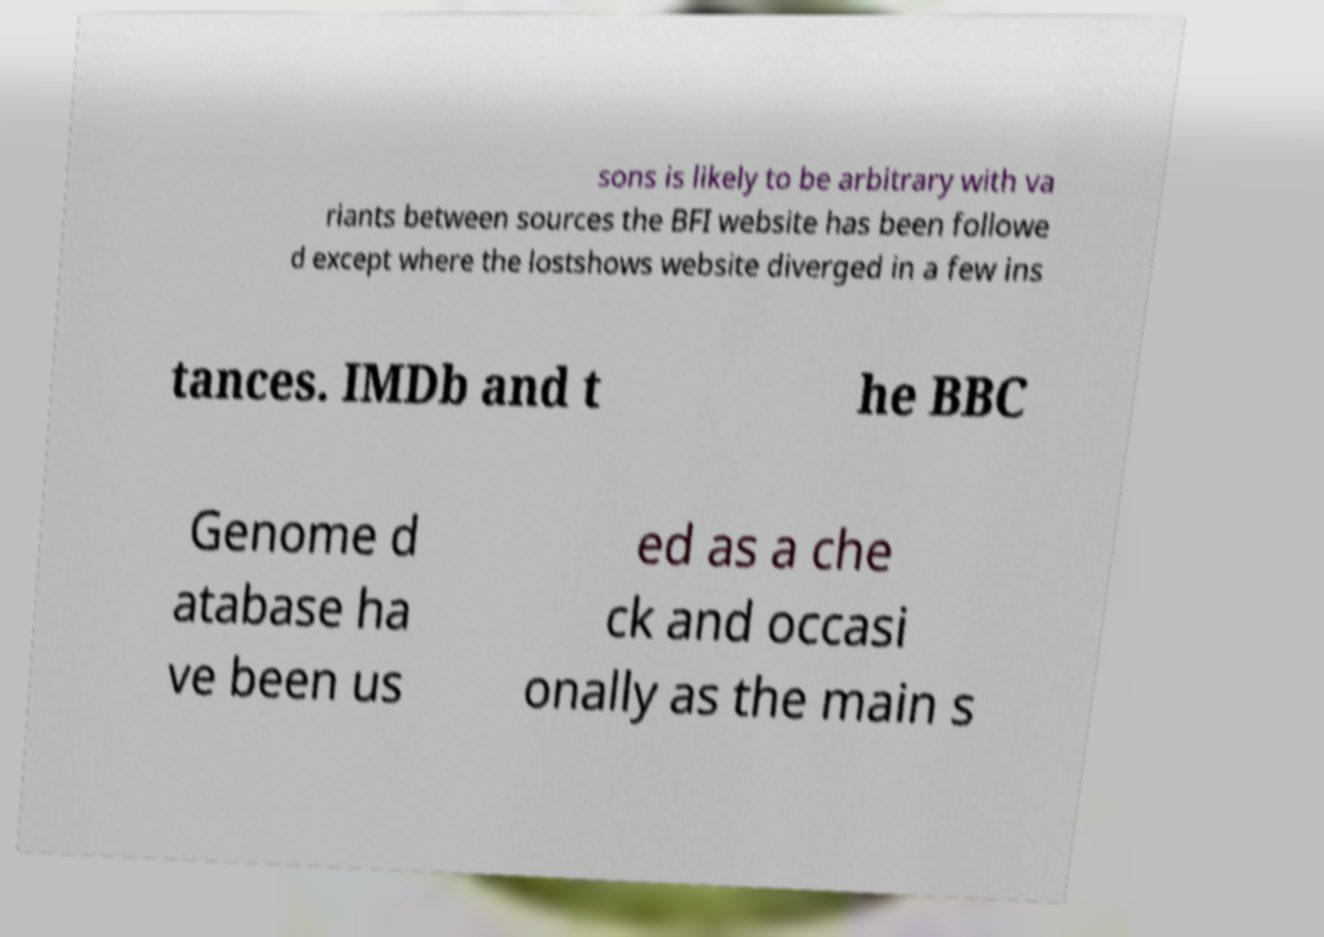Please read and relay the text visible in this image. What does it say? sons is likely to be arbitrary with va riants between sources the BFI website has been followe d except where the lostshows website diverged in a few ins tances. IMDb and t he BBC Genome d atabase ha ve been us ed as a che ck and occasi onally as the main s 